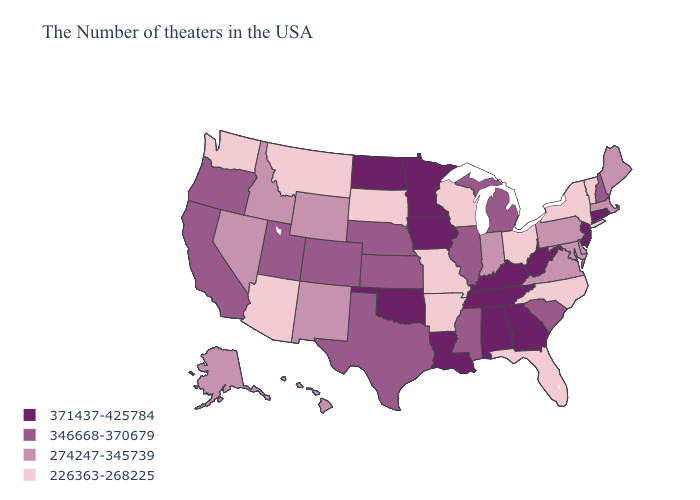Does Nebraska have the lowest value in the USA?
Give a very brief answer. No. Name the states that have a value in the range 371437-425784?
Be succinct. Rhode Island, Connecticut, New Jersey, West Virginia, Georgia, Kentucky, Alabama, Tennessee, Louisiana, Minnesota, Iowa, Oklahoma, North Dakota. Does Hawaii have the highest value in the USA?
Give a very brief answer. No. What is the value of Vermont?
Give a very brief answer. 226363-268225. What is the lowest value in the MidWest?
Give a very brief answer. 226363-268225. Which states have the highest value in the USA?
Keep it brief. Rhode Island, Connecticut, New Jersey, West Virginia, Georgia, Kentucky, Alabama, Tennessee, Louisiana, Minnesota, Iowa, Oklahoma, North Dakota. What is the lowest value in the USA?
Answer briefly. 226363-268225. Does Nevada have a lower value than Illinois?
Be succinct. Yes. What is the value of Louisiana?
Write a very short answer. 371437-425784. Does Tennessee have the lowest value in the USA?
Concise answer only. No. Name the states that have a value in the range 346668-370679?
Concise answer only. New Hampshire, South Carolina, Michigan, Illinois, Mississippi, Kansas, Nebraska, Texas, Colorado, Utah, California, Oregon. Among the states that border Delaware , which have the lowest value?
Keep it brief. Maryland, Pennsylvania. Name the states that have a value in the range 346668-370679?
Short answer required. New Hampshire, South Carolina, Michigan, Illinois, Mississippi, Kansas, Nebraska, Texas, Colorado, Utah, California, Oregon. Does Vermont have the same value as Massachusetts?
Short answer required. No. Does the map have missing data?
Concise answer only. No. 